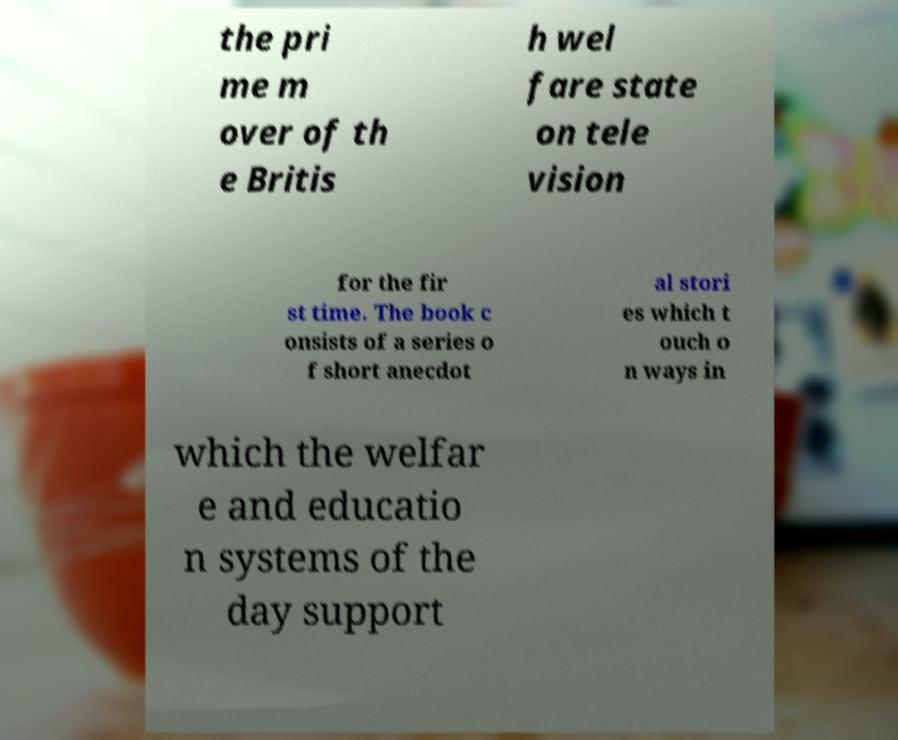Could you extract and type out the text from this image? the pri me m over of th e Britis h wel fare state on tele vision for the fir st time. The book c onsists of a series o f short anecdot al stori es which t ouch o n ways in which the welfar e and educatio n systems of the day support 